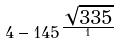<formula> <loc_0><loc_0><loc_500><loc_500>4 - 1 4 5 ^ { \frac { \sqrt { 3 3 5 } } { 1 } }</formula> 